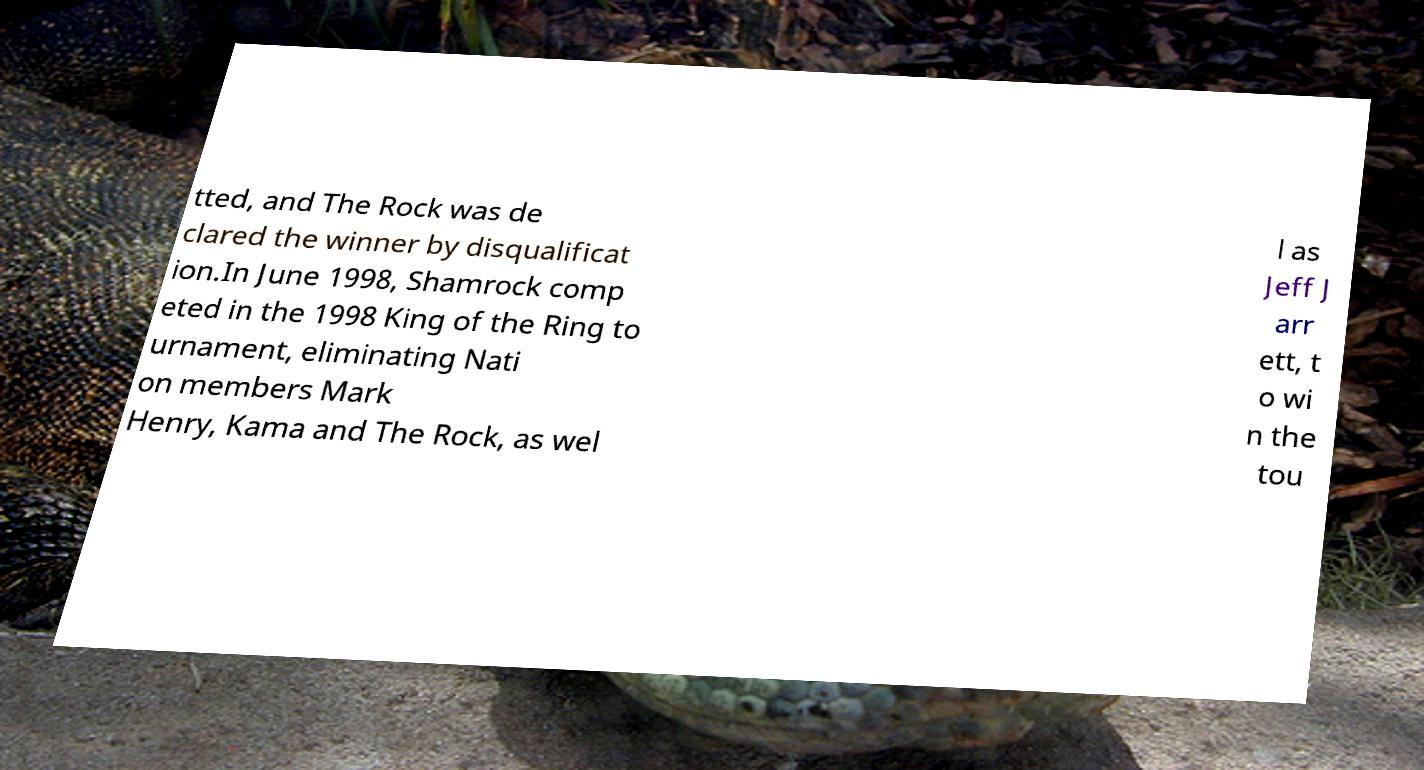For documentation purposes, I need the text within this image transcribed. Could you provide that? tted, and The Rock was de clared the winner by disqualificat ion.In June 1998, Shamrock comp eted in the 1998 King of the Ring to urnament, eliminating Nati on members Mark Henry, Kama and The Rock, as wel l as Jeff J arr ett, t o wi n the tou 